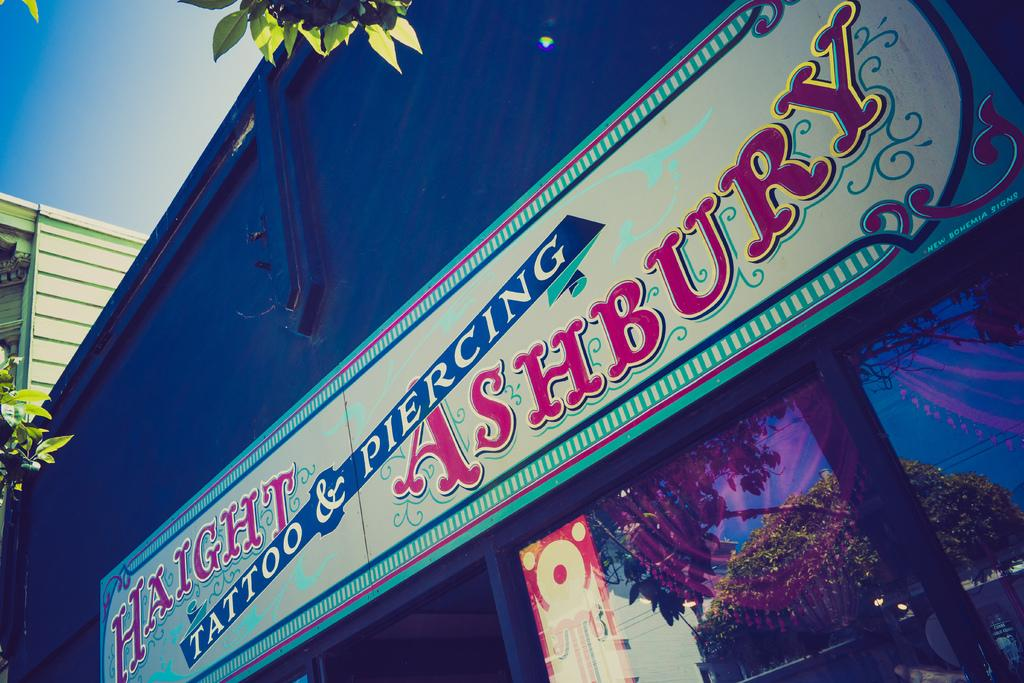What is visible at the top of the image? The sky is visible at the top of the image. What type of vegetation is present in the image? There are green leaves in the image. What can be found in addition to the green leaves? There is text or writing in the image. What is reflected on the glass in the image? There is a reflection of a tree on the glass, and wires are visible in the reflection. Can you tell me how many words are written on the lead in the image? There is no lead or specific number of words mentioned in the image; it only states that there is text or writing present. 